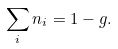<formula> <loc_0><loc_0><loc_500><loc_500>\sum _ { i } n _ { i } = 1 - g .</formula> 